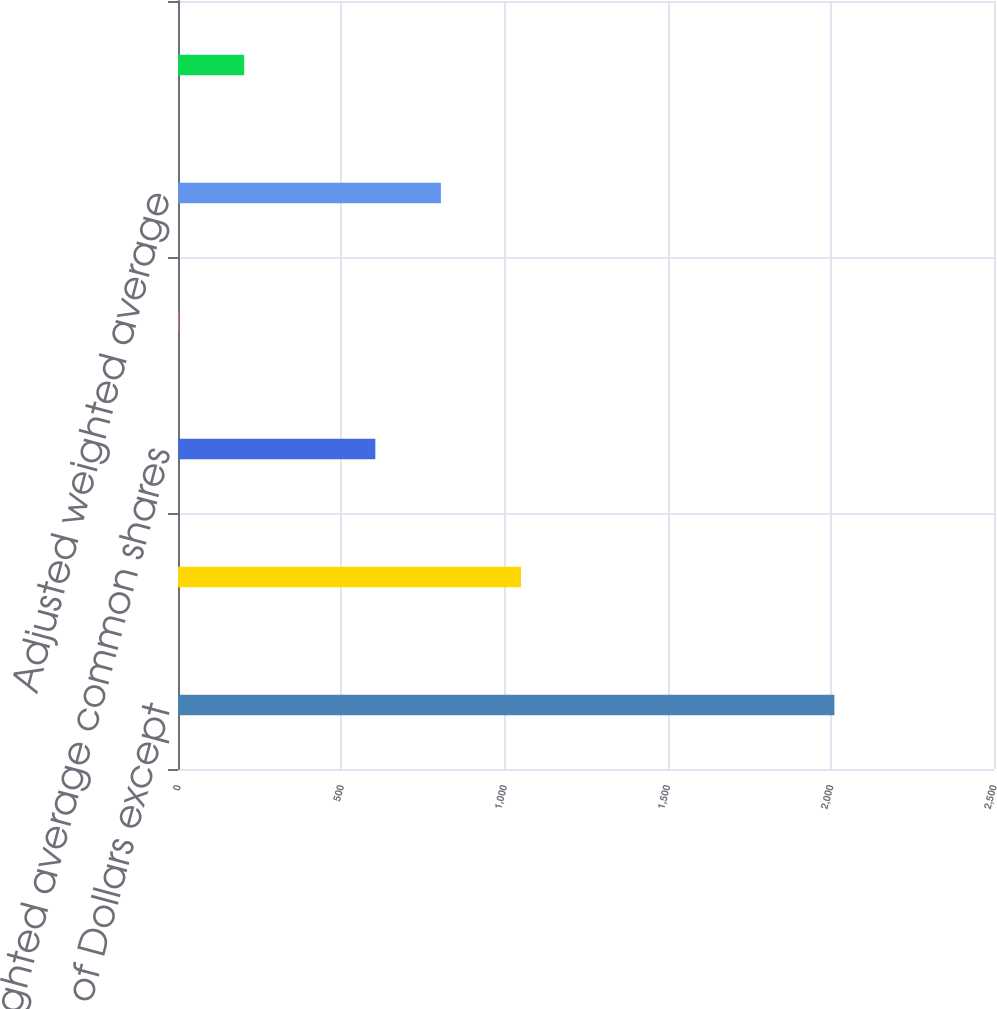<chart> <loc_0><loc_0><loc_500><loc_500><bar_chart><fcel>(Millions of Dollars except<fcel>Net income for common stock<fcel>Weighted average common shares<fcel>Add Incremental shares<fcel>Adjusted weighted average<fcel>Net Income for common stock<nl><fcel>2011<fcel>1051<fcel>604.56<fcel>1.8<fcel>805.48<fcel>202.72<nl></chart> 